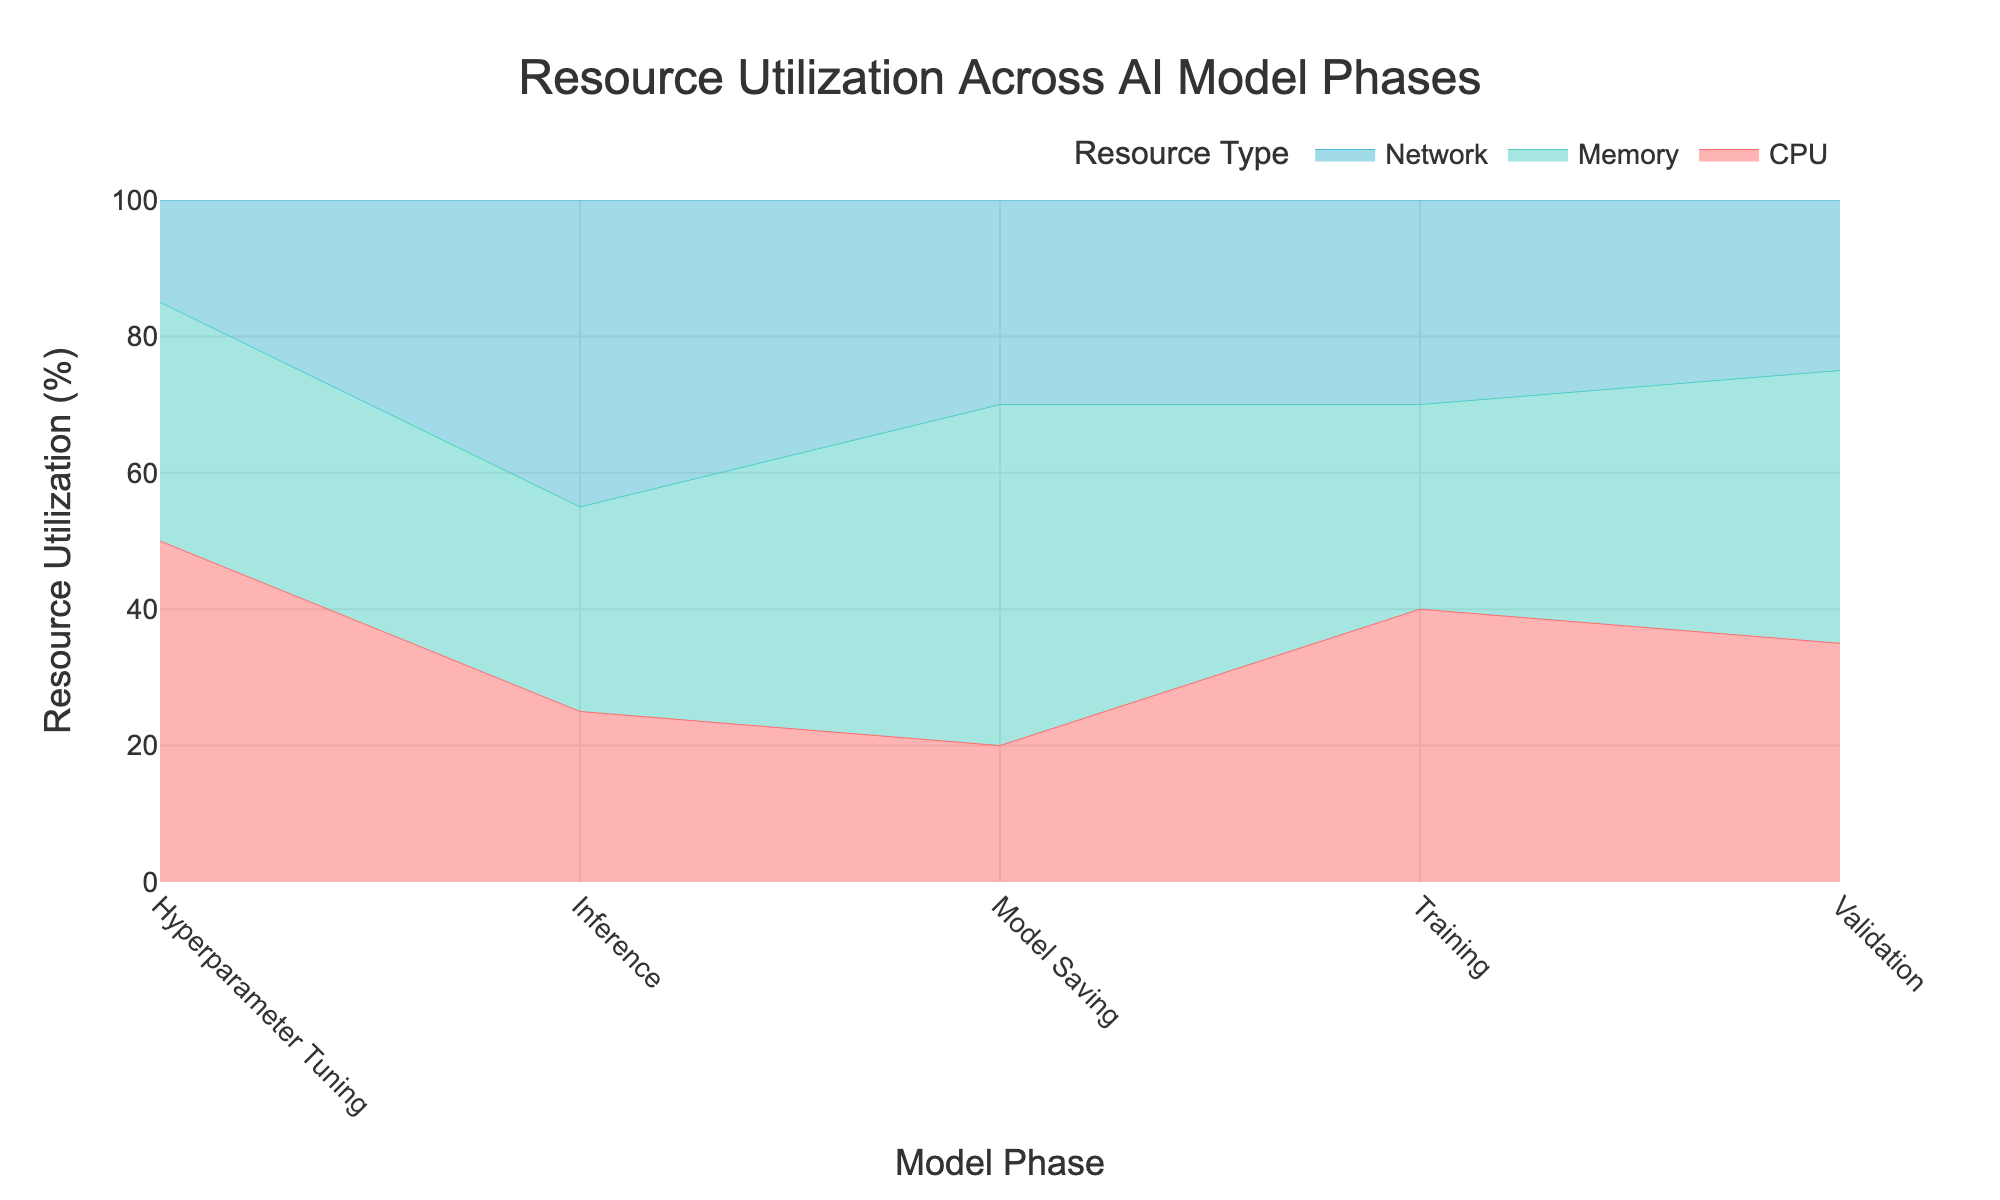What's the title of the chart? The title of the chart is located at the top and provides a summary of the data being visualized. In this case, the title reads "Resource Utilization Across AI Model Phases."
Answer: Resource Utilization Across AI Model Phases Which resource has the highest utilization during the Training phase? By examining the Training phase in the chart, we observe the three resources: CPU, Memory, and Network. The highest segment in this phase belongs to the CPU.
Answer: CPU How much Memory is utilized during Inference? By looking at the Inference phase in the chart, we see the Memory segment's size. According to the data, Memory utilization is 30%.
Answer: 30% What is the difference in CPU utilization between Hyperparameter Tuning and Model Saving phases? For Hyperparameter Tuning, CPU utilization is 50%, and for Model Saving, it is 20%. The difference is calculated as 50% - 20% = 30%.
Answer: 30% Which phase has the least Network utilization? By comparing the Network segments across all phases, we see that Hyperparameter Tuning has the smallest segment, indicating the least utilization, at 15%.
Answer: Hyperparameter Tuning What is the combined Memory utilization for Training and Validation phases? Memory utilization for Training is 30%, and for Validation, it is 40%. Adding these values gives 30% + 40% = 70%.
Answer: 70% During which phase does Network utilization peak? By observing the height of the Network segments in each phase, Inference has the highest segment with Network utilization at 45%.
Answer: Inference How does CPU utilization in Inference compare to Training? CPU utilization in Inference is 25%, while in Training it is 40%. Therefore, CPU utilization in Inference is less than in Training.
Answer: less Which resource shows the most consistent utilization across all phases? By visually assessing the heights of the segments, Memory shows the most even spread without drastic changes across the phases.
Answer: Memory 